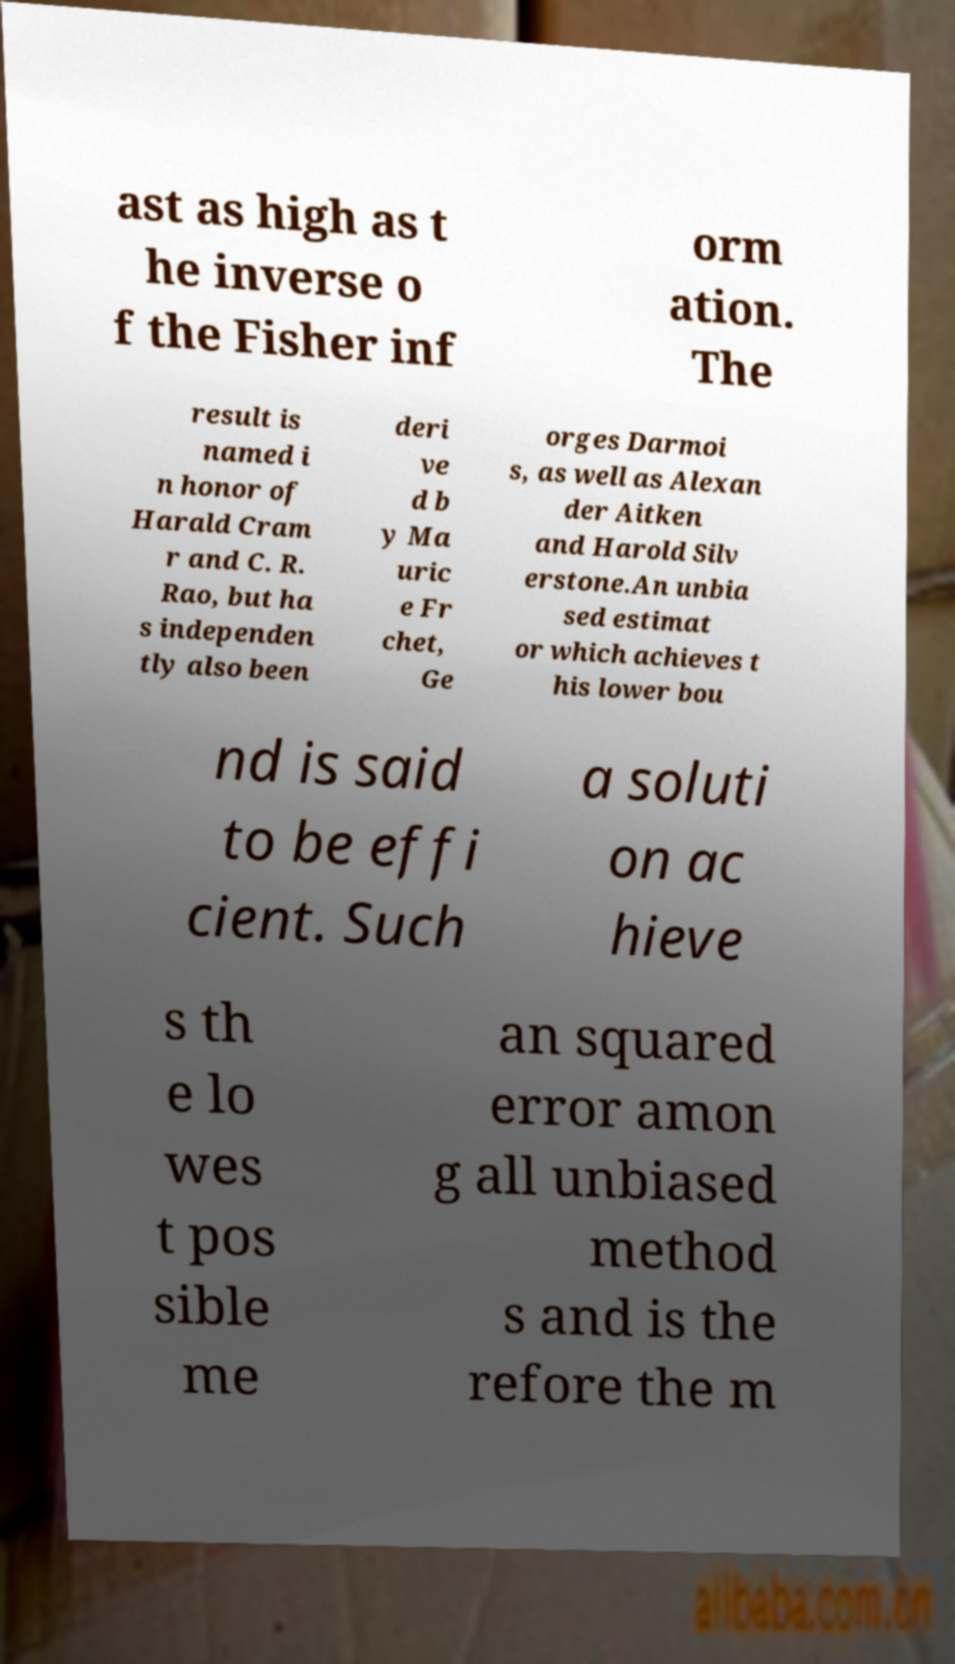Could you assist in decoding the text presented in this image and type it out clearly? ast as high as t he inverse o f the Fisher inf orm ation. The result is named i n honor of Harald Cram r and C. R. Rao, but ha s independen tly also been deri ve d b y Ma uric e Fr chet, Ge orges Darmoi s, as well as Alexan der Aitken and Harold Silv erstone.An unbia sed estimat or which achieves t his lower bou nd is said to be effi cient. Such a soluti on ac hieve s th e lo wes t pos sible me an squared error amon g all unbiased method s and is the refore the m 